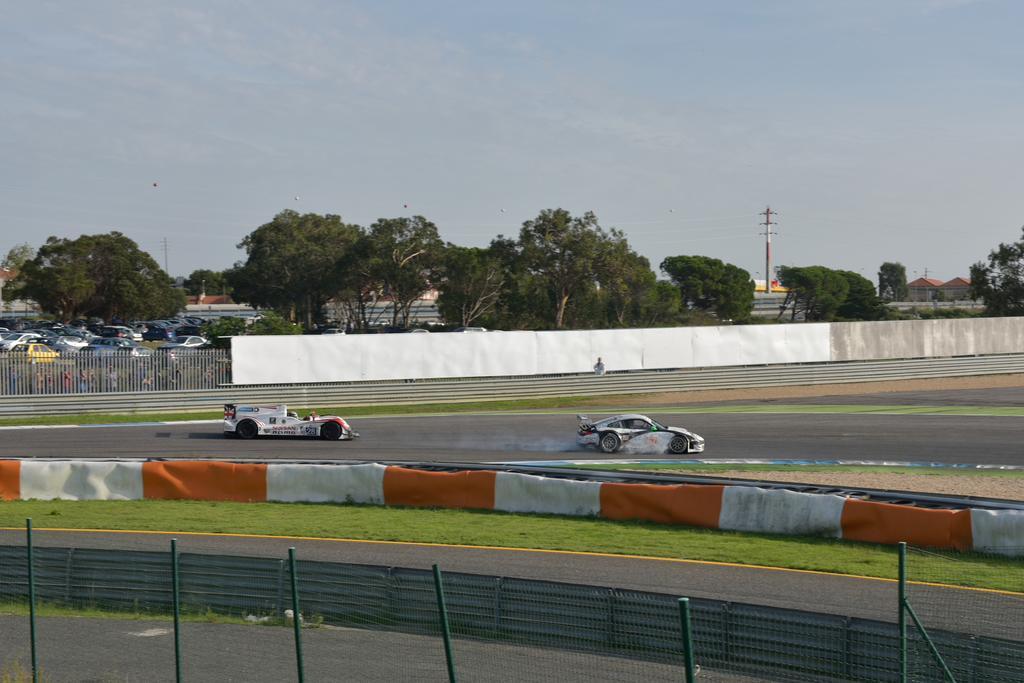Please provide a concise description of this image. In this picture we can see there are two sports cars on the road and on the right side of the cars there is a fence and behind the cars there is an iron fence boards and some vehicles on the path. Behind the vehicles there are trees, an electric pole and the sky. 